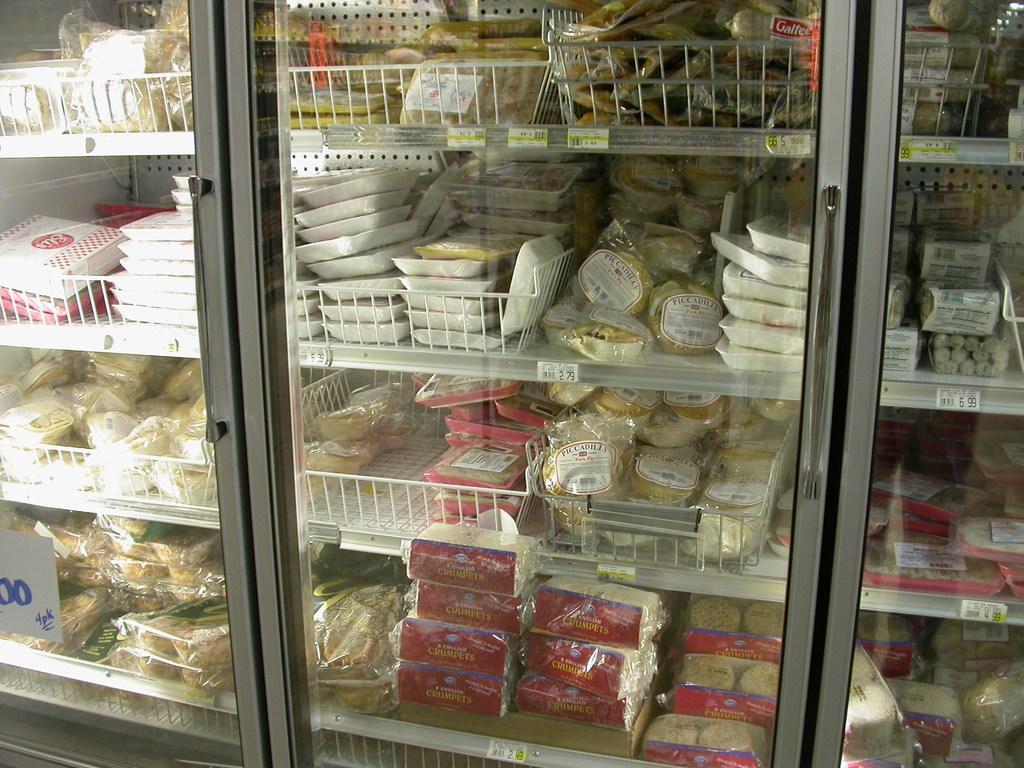Can you describe this image briefly? We can see boxes, packets, food items and objects are on the racks and we can sticker on glass door. 